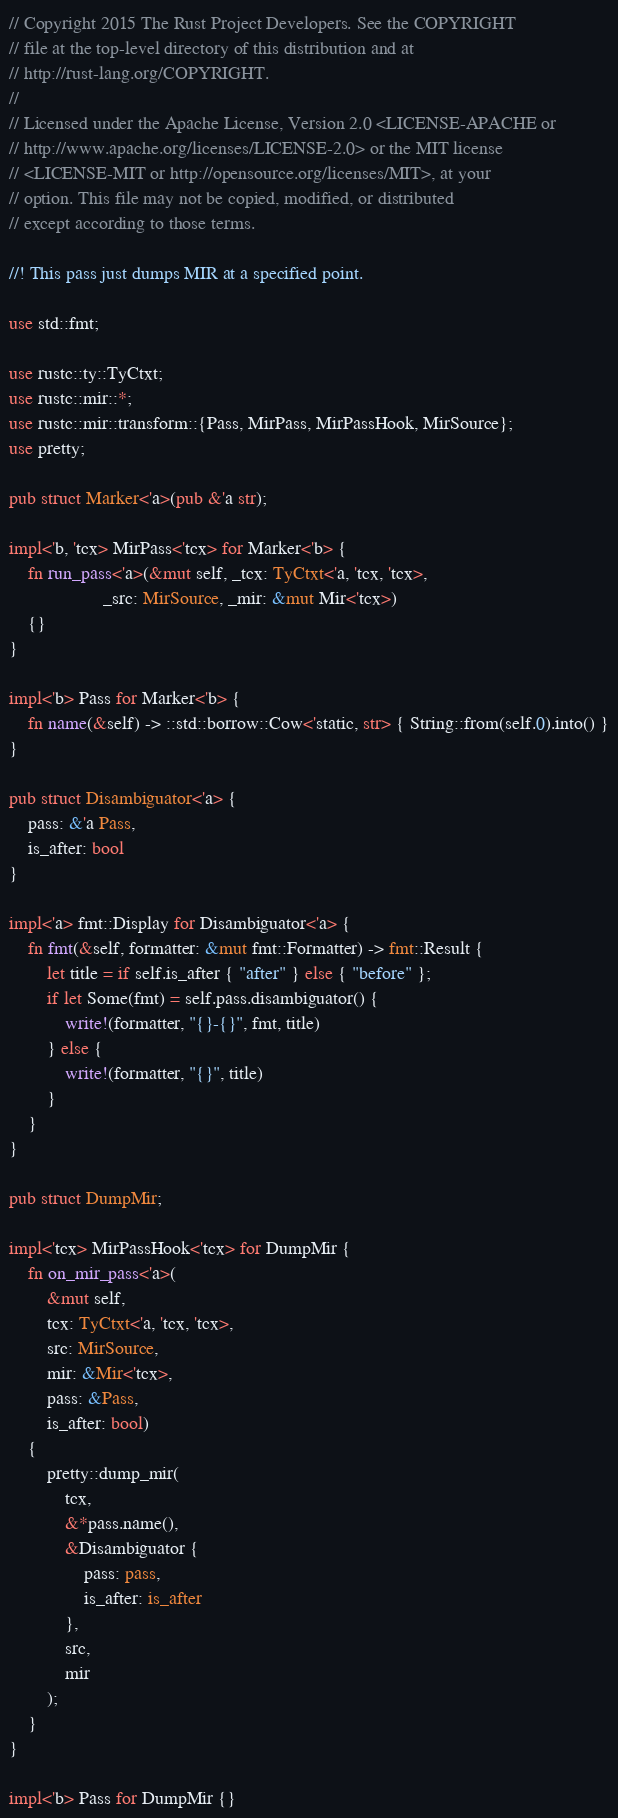Convert code to text. <code><loc_0><loc_0><loc_500><loc_500><_Rust_>// Copyright 2015 The Rust Project Developers. See the COPYRIGHT
// file at the top-level directory of this distribution and at
// http://rust-lang.org/COPYRIGHT.
//
// Licensed under the Apache License, Version 2.0 <LICENSE-APACHE or
// http://www.apache.org/licenses/LICENSE-2.0> or the MIT license
// <LICENSE-MIT or http://opensource.org/licenses/MIT>, at your
// option. This file may not be copied, modified, or distributed
// except according to those terms.

//! This pass just dumps MIR at a specified point.

use std::fmt;

use rustc::ty::TyCtxt;
use rustc::mir::*;
use rustc::mir::transform::{Pass, MirPass, MirPassHook, MirSource};
use pretty;

pub struct Marker<'a>(pub &'a str);

impl<'b, 'tcx> MirPass<'tcx> for Marker<'b> {
    fn run_pass<'a>(&mut self, _tcx: TyCtxt<'a, 'tcx, 'tcx>,
                    _src: MirSource, _mir: &mut Mir<'tcx>)
    {}
}

impl<'b> Pass for Marker<'b> {
    fn name(&self) -> ::std::borrow::Cow<'static, str> { String::from(self.0).into() }
}

pub struct Disambiguator<'a> {
    pass: &'a Pass,
    is_after: bool
}

impl<'a> fmt::Display for Disambiguator<'a> {
    fn fmt(&self, formatter: &mut fmt::Formatter) -> fmt::Result {
        let title = if self.is_after { "after" } else { "before" };
        if let Some(fmt) = self.pass.disambiguator() {
            write!(formatter, "{}-{}", fmt, title)
        } else {
            write!(formatter, "{}", title)
        }
    }
}

pub struct DumpMir;

impl<'tcx> MirPassHook<'tcx> for DumpMir {
    fn on_mir_pass<'a>(
        &mut self,
        tcx: TyCtxt<'a, 'tcx, 'tcx>,
        src: MirSource,
        mir: &Mir<'tcx>,
        pass: &Pass,
        is_after: bool)
    {
        pretty::dump_mir(
            tcx,
            &*pass.name(),
            &Disambiguator {
                pass: pass,
                is_after: is_after
            },
            src,
            mir
        );
    }
}

impl<'b> Pass for DumpMir {}
</code> 